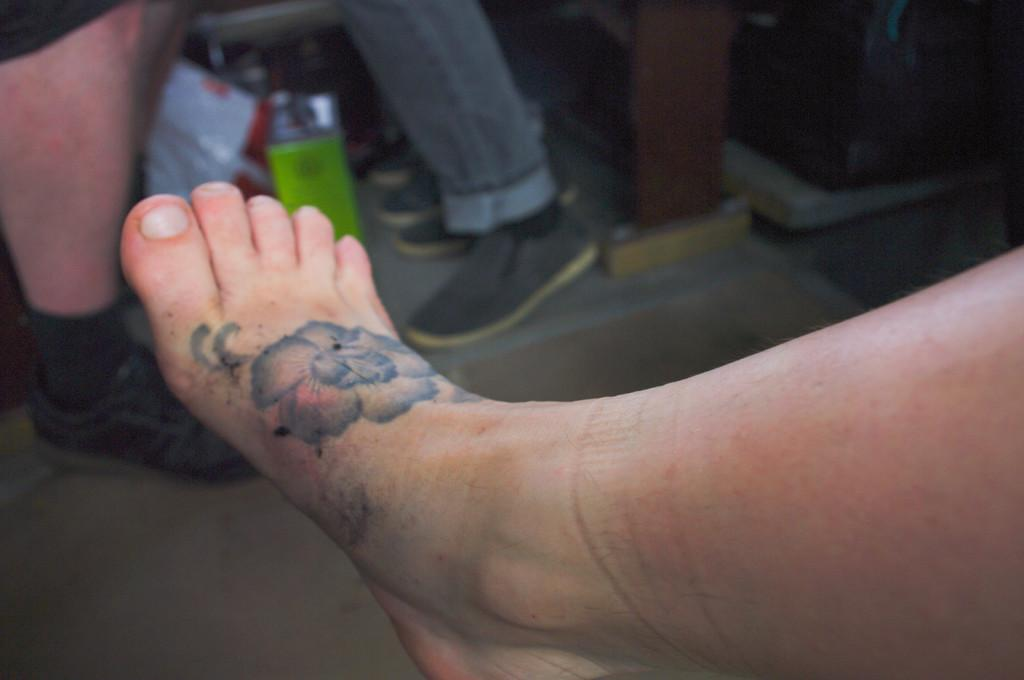What is depicted on the human leg in the image? There is a tattoo on a human leg in the image. How many parents does the tattoo have in the image? The tattoo is an inanimate object and does not have parents. 